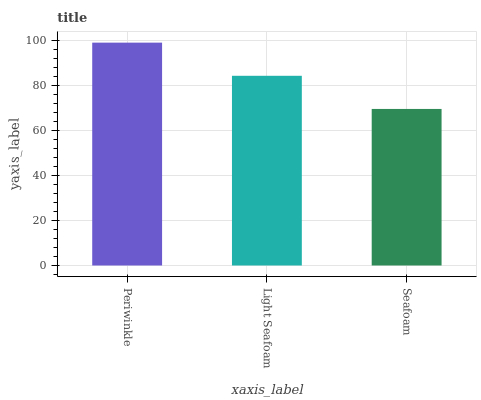Is Seafoam the minimum?
Answer yes or no. Yes. Is Periwinkle the maximum?
Answer yes or no. Yes. Is Light Seafoam the minimum?
Answer yes or no. No. Is Light Seafoam the maximum?
Answer yes or no. No. Is Periwinkle greater than Light Seafoam?
Answer yes or no. Yes. Is Light Seafoam less than Periwinkle?
Answer yes or no. Yes. Is Light Seafoam greater than Periwinkle?
Answer yes or no. No. Is Periwinkle less than Light Seafoam?
Answer yes or no. No. Is Light Seafoam the high median?
Answer yes or no. Yes. Is Light Seafoam the low median?
Answer yes or no. Yes. Is Seafoam the high median?
Answer yes or no. No. Is Periwinkle the low median?
Answer yes or no. No. 